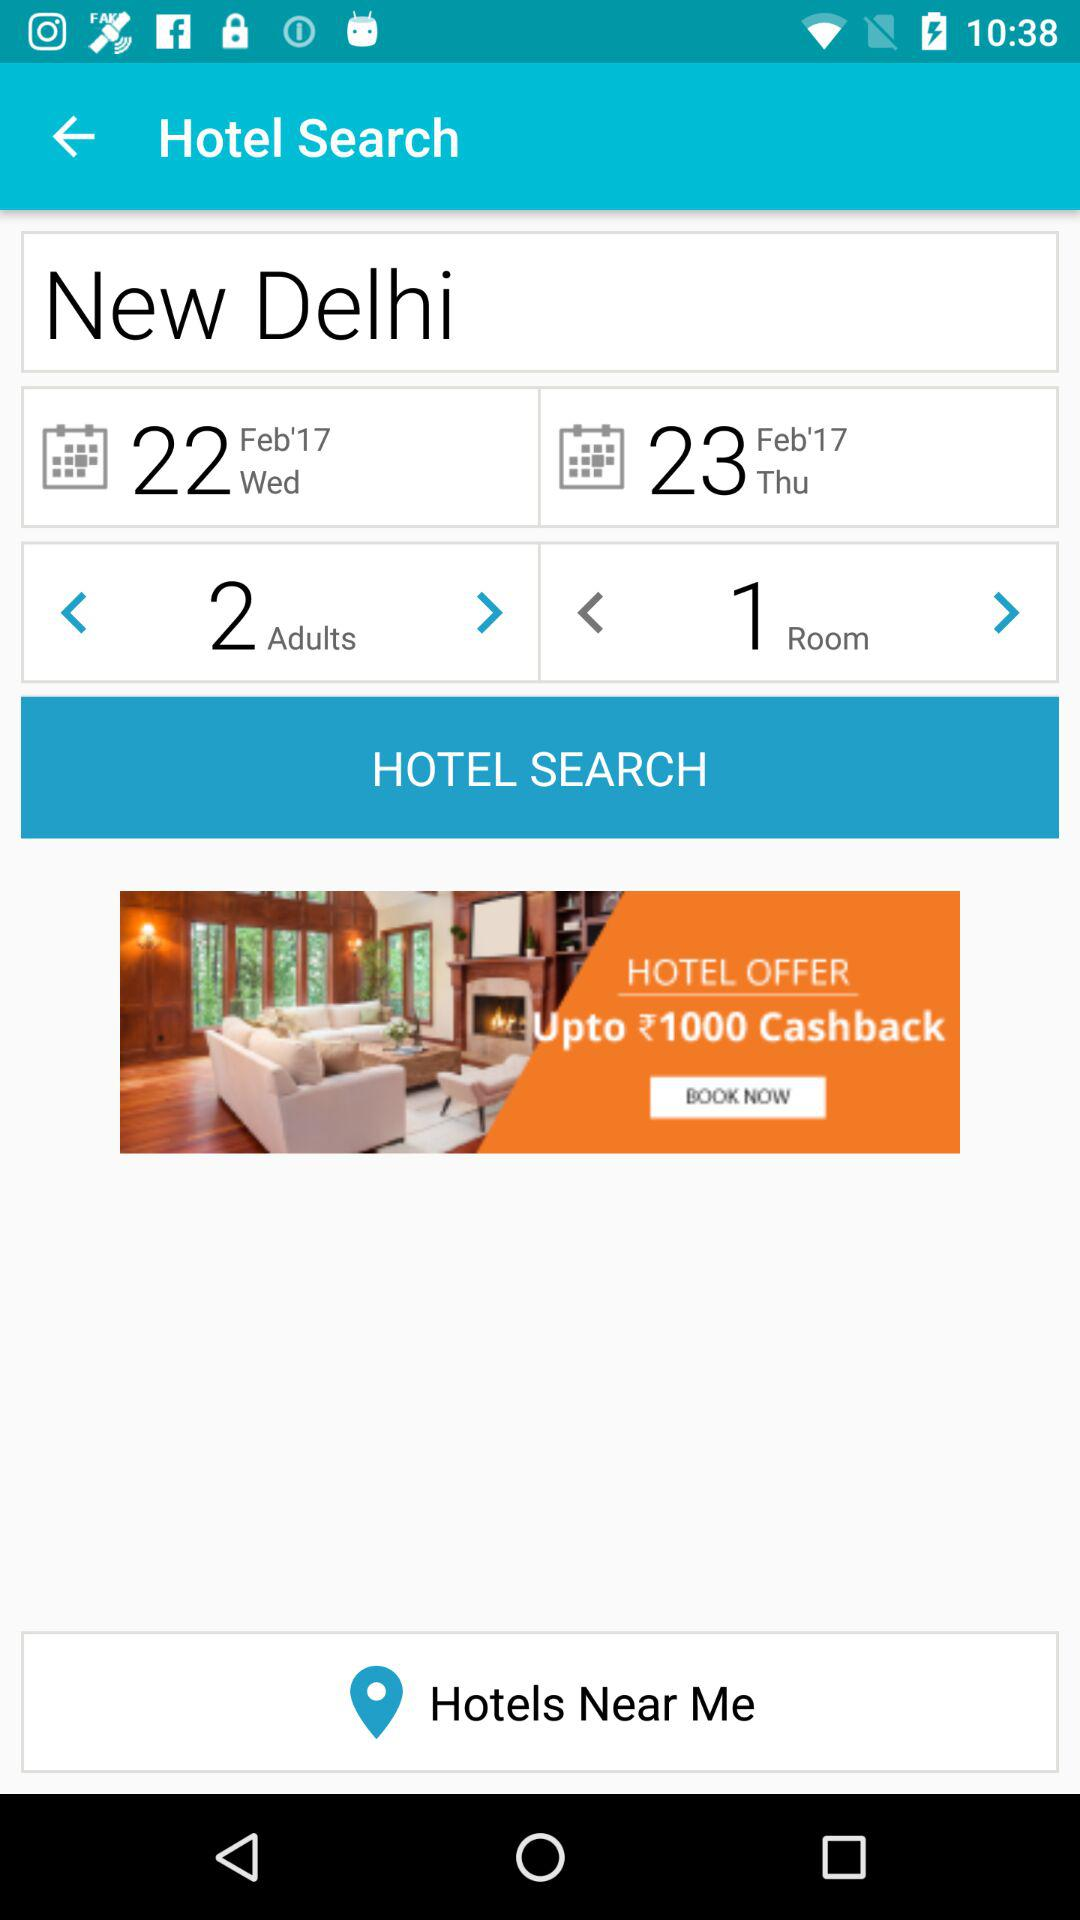How many more adults are there than rooms?
Answer the question using a single word or phrase. 1 